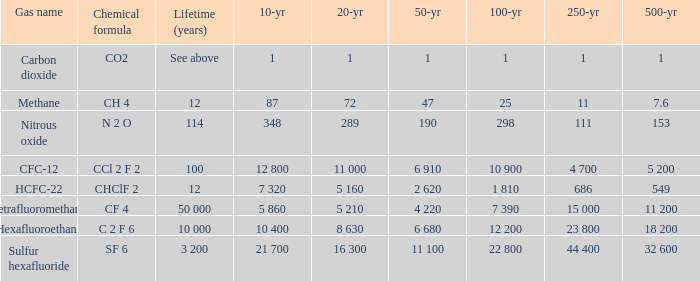What is the 500 year where 20 year is 289? 153.0. 